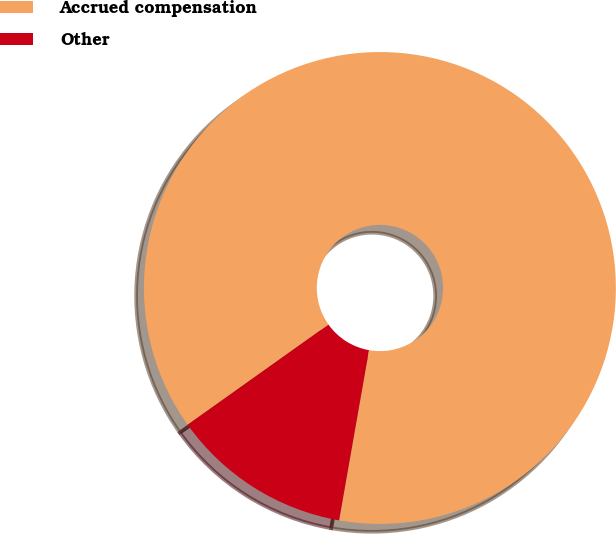<chart> <loc_0><loc_0><loc_500><loc_500><pie_chart><fcel>Accrued compensation<fcel>Other<nl><fcel>87.61%<fcel>12.39%<nl></chart> 